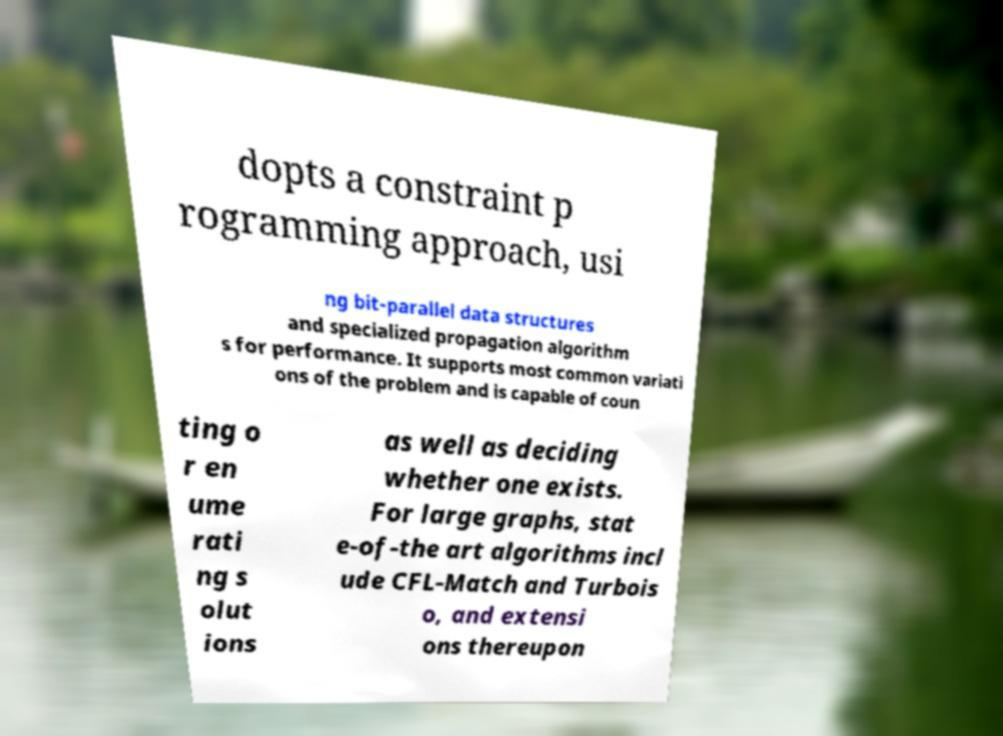I need the written content from this picture converted into text. Can you do that? dopts a constraint p rogramming approach, usi ng bit-parallel data structures and specialized propagation algorithm s for performance. It supports most common variati ons of the problem and is capable of coun ting o r en ume rati ng s olut ions as well as deciding whether one exists. For large graphs, stat e-of-the art algorithms incl ude CFL-Match and Turbois o, and extensi ons thereupon 